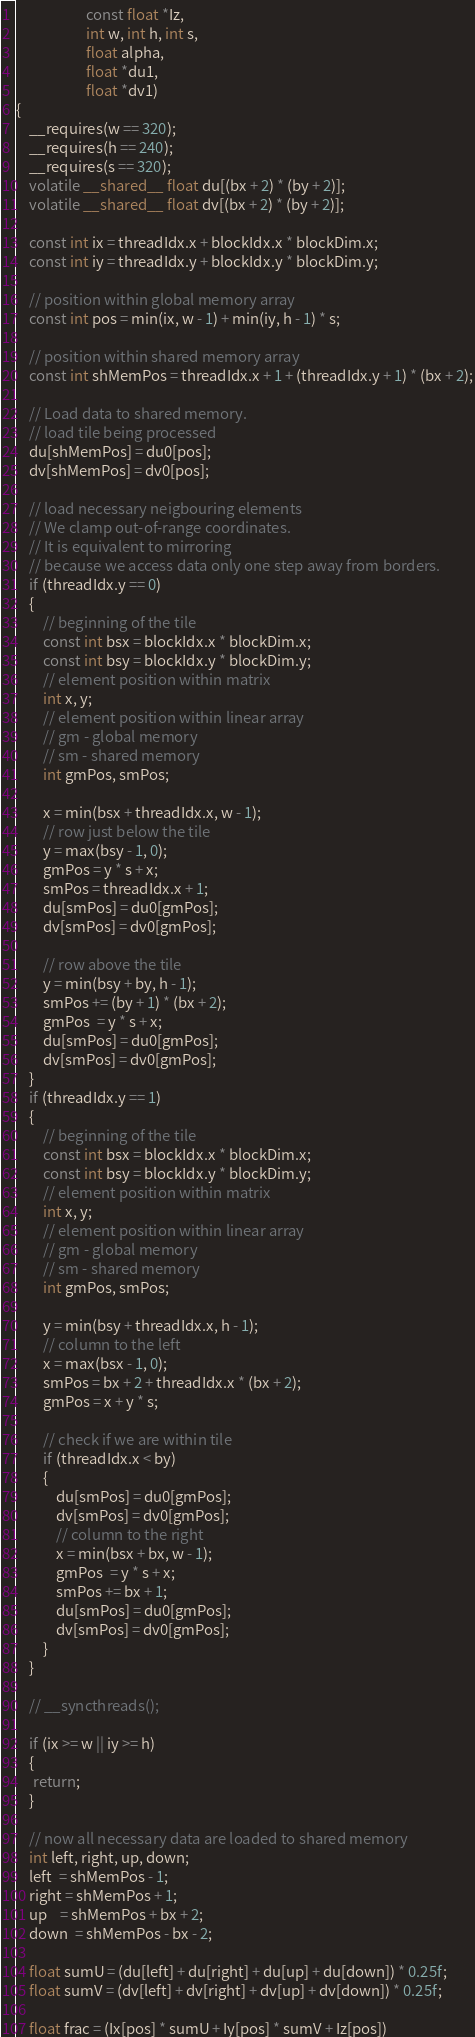<code> <loc_0><loc_0><loc_500><loc_500><_Cuda_>                     const float *Iz,
                     int w, int h, int s,
                     float alpha,
                     float *du1,
                     float *dv1)
{
    __requires(w == 320);
    __requires(h == 240);
    __requires(s == 320);
    volatile __shared__ float du[(bx + 2) * (by + 2)];
    volatile __shared__ float dv[(bx + 2) * (by + 2)];

    const int ix = threadIdx.x + blockIdx.x * blockDim.x;
    const int iy = threadIdx.y + blockIdx.y * blockDim.y;

    // position within global memory array
    const int pos = min(ix, w - 1) + min(iy, h - 1) * s;

    // position within shared memory array
    const int shMemPos = threadIdx.x + 1 + (threadIdx.y + 1) * (bx + 2);

    // Load data to shared memory.
    // load tile being processed
    du[shMemPos] = du0[pos];
    dv[shMemPos] = dv0[pos];

    // load necessary neigbouring elements
    // We clamp out-of-range coordinates.
    // It is equivalent to mirroring
    // because we access data only one step away from borders.
    if (threadIdx.y == 0)
    {
        // beginning of the tile
        const int bsx = blockIdx.x * blockDim.x;
        const int bsy = blockIdx.y * blockDim.y;
        // element position within matrix
        int x, y;
        // element position within linear array
        // gm - global memory
        // sm - shared memory
        int gmPos, smPos;

        x = min(bsx + threadIdx.x, w - 1);
        // row just below the tile
        y = max(bsy - 1, 0);
        gmPos = y * s + x;
        smPos = threadIdx.x + 1;
        du[smPos] = du0[gmPos];
        dv[smPos] = dv0[gmPos];

        // row above the tile
        y = min(bsy + by, h - 1);
        smPos += (by + 1) * (bx + 2);
        gmPos  = y * s + x;
        du[smPos] = du0[gmPos];
        dv[smPos] = dv0[gmPos];
    }
    if (threadIdx.y == 1)
    {
        // beginning of the tile
        const int bsx = blockIdx.x * blockDim.x;
        const int bsy = blockIdx.y * blockDim.y;
        // element position within matrix
        int x, y;
        // element position within linear array
        // gm - global memory
        // sm - shared memory
        int gmPos, smPos;

        y = min(bsy + threadIdx.x, h - 1);
        // column to the left
        x = max(bsx - 1, 0);
        smPos = bx + 2 + threadIdx.x * (bx + 2);
        gmPos = x + y * s;

        // check if we are within tile
        if (threadIdx.x < by)
        {
            du[smPos] = du0[gmPos];
            dv[smPos] = dv0[gmPos];
            // column to the right
            x = min(bsx + bx, w - 1);
            gmPos  = y * s + x;
            smPos += bx + 1;
            du[smPos] = du0[gmPos];
            dv[smPos] = dv0[gmPos];
        }
    }

    // __syncthreads();

    if (ix >= w || iy >= h)
    {
     return;
    }

    // now all necessary data are loaded to shared memory
    int left, right, up, down;
    left  = shMemPos - 1;
    right = shMemPos + 1;
    up    = shMemPos + bx + 2;
    down  = shMemPos - bx - 2;

    float sumU = (du[left] + du[right] + du[up] + du[down]) * 0.25f;
    float sumV = (dv[left] + dv[right] + dv[up] + dv[down]) * 0.25f;

    float frac = (Ix[pos] * sumU + Iy[pos] * sumV + Iz[pos])</code> 